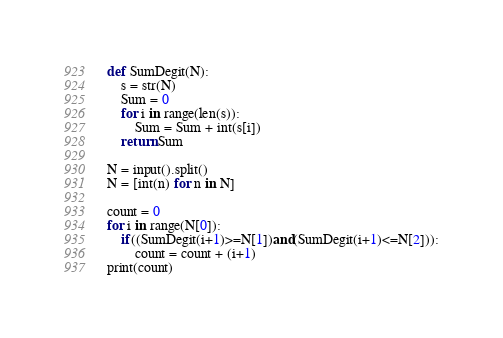<code> <loc_0><loc_0><loc_500><loc_500><_Python_>def SumDegit(N):
    s = str(N)
    Sum = 0
    for i in range(len(s)):
        Sum = Sum + int(s[i])
    return Sum

N = input().split()
N = [int(n) for n in N]

count = 0
for i in range(N[0]):
    if((SumDegit(i+1)>=N[1])and(SumDegit(i+1)<=N[2])):
        count = count + (i+1)
print(count)
</code> 